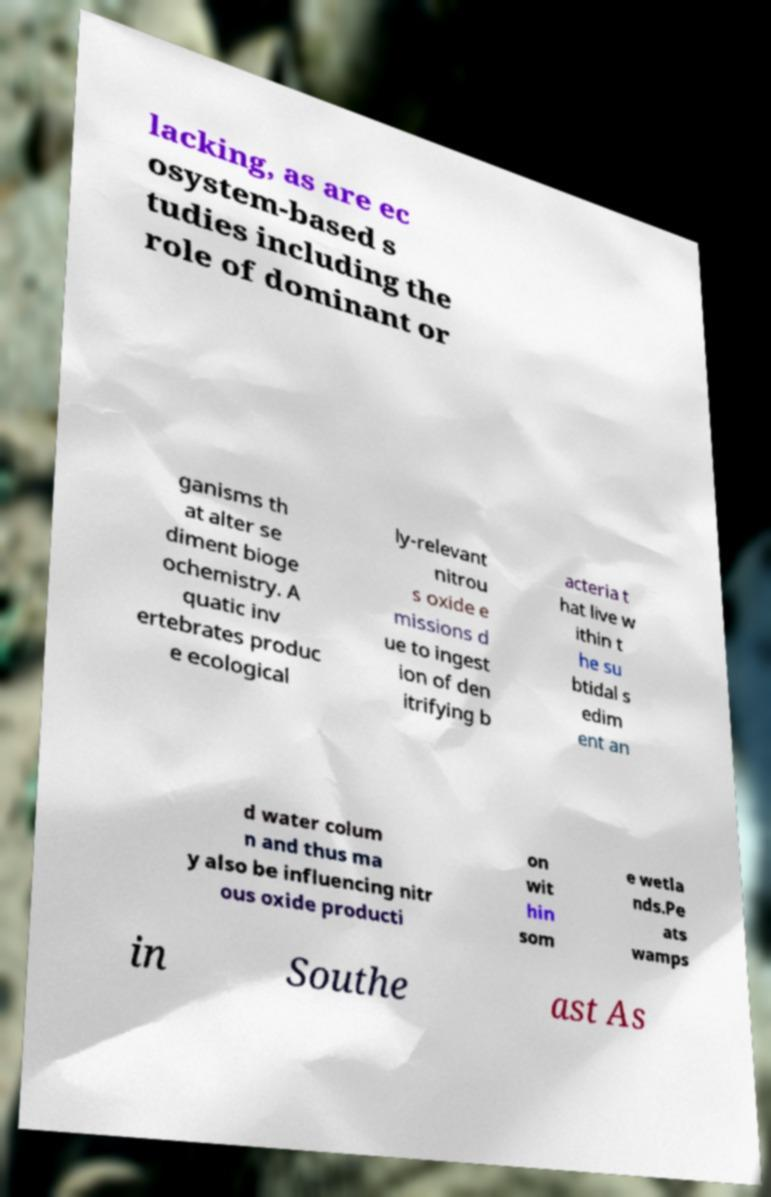Can you accurately transcribe the text from the provided image for me? lacking, as are ec osystem-based s tudies including the role of dominant or ganisms th at alter se diment bioge ochemistry. A quatic inv ertebrates produc e ecological ly-relevant nitrou s oxide e missions d ue to ingest ion of den itrifying b acteria t hat live w ithin t he su btidal s edim ent an d water colum n and thus ma y also be influencing nitr ous oxide producti on wit hin som e wetla nds.Pe ats wamps in Southe ast As 